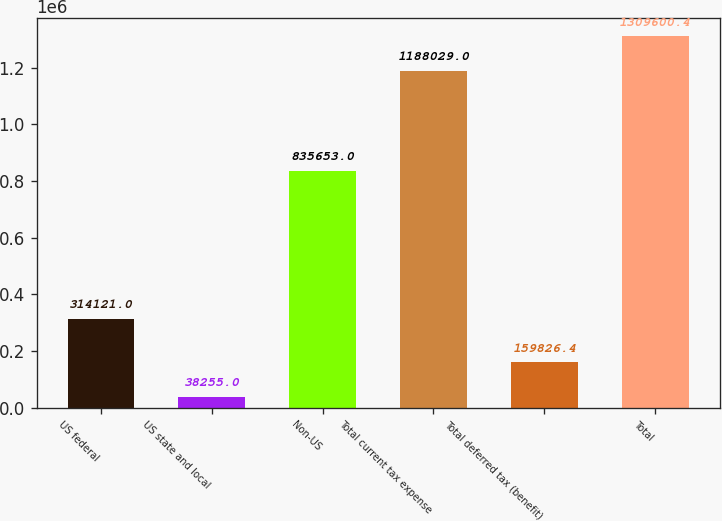<chart> <loc_0><loc_0><loc_500><loc_500><bar_chart><fcel>US federal<fcel>US state and local<fcel>Non-US<fcel>Total current tax expense<fcel>Total deferred tax (benefit)<fcel>Total<nl><fcel>314121<fcel>38255<fcel>835653<fcel>1.18803e+06<fcel>159826<fcel>1.3096e+06<nl></chart> 